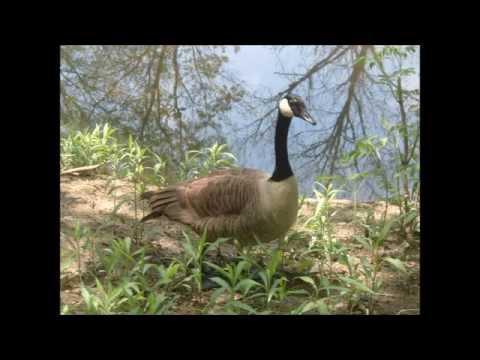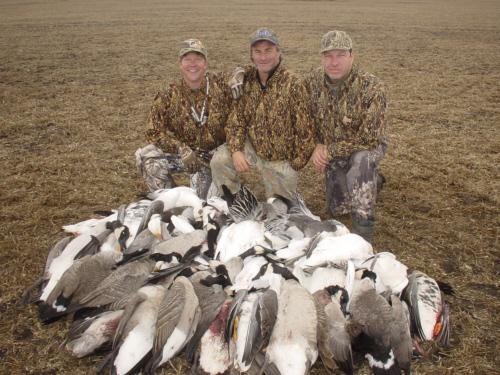The first image is the image on the left, the second image is the image on the right. Given the left and right images, does the statement "The right image contains exactly one duck." hold true? Answer yes or no. No. The first image is the image on the left, the second image is the image on the right. Given the left and right images, does the statement "The combined images include two geese with grey coloring bending their grey necks toward the grass." hold true? Answer yes or no. No. 